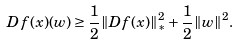Convert formula to latex. <formula><loc_0><loc_0><loc_500><loc_500>D f ( x ) ( w ) \geq \frac { 1 } { 2 } \| D f ( x ) \| _ { * } ^ { 2 } + \frac { 1 } { 2 } \| w \| ^ { 2 } .</formula> 